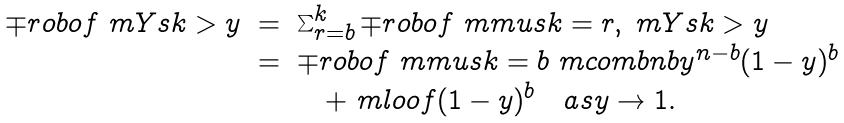Convert formula to latex. <formula><loc_0><loc_0><loc_500><loc_500>\begin{array} { c l l } \mp r o b o f { \ m Y s { k } > y } & = & \sum _ { r = b } ^ { k } \mp r o b o f { \ m m u s { k } = r , \ m Y s { k } > y } \\ & = & \mp r o b o f { \ m m u s { k } = b } \ m c o m b { n } { b } y ^ { n - b } ( 1 - y ) ^ { b } \\ & & \quad + \ m l o o f { ( 1 - y ) ^ { b } } \quad a s y \to 1 . \end{array}</formula> 